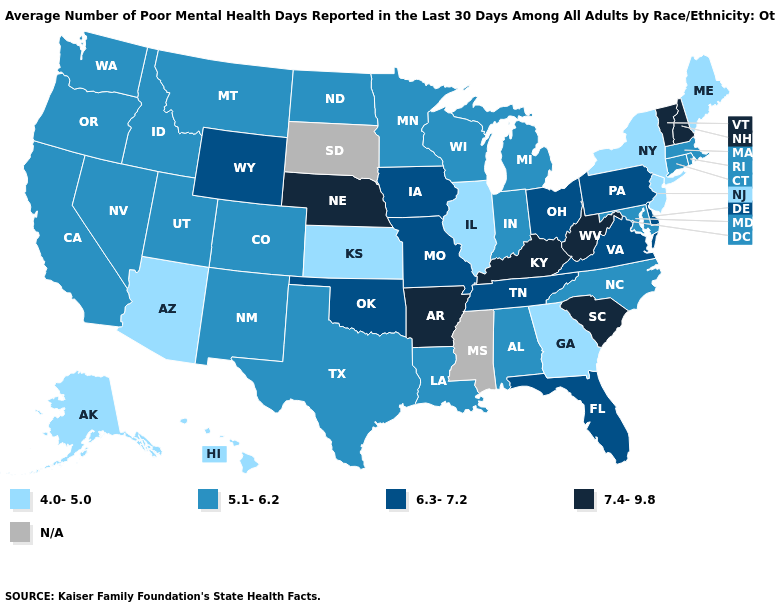Does Vermont have the highest value in the Northeast?
Keep it brief. Yes. Name the states that have a value in the range 5.1-6.2?
Concise answer only. Alabama, California, Colorado, Connecticut, Idaho, Indiana, Louisiana, Maryland, Massachusetts, Michigan, Minnesota, Montana, Nevada, New Mexico, North Carolina, North Dakota, Oregon, Rhode Island, Texas, Utah, Washington, Wisconsin. Among the states that border Missouri , which have the lowest value?
Give a very brief answer. Illinois, Kansas. What is the lowest value in the MidWest?
Short answer required. 4.0-5.0. What is the lowest value in states that border Louisiana?
Write a very short answer. 5.1-6.2. Which states have the lowest value in the MidWest?
Be succinct. Illinois, Kansas. Name the states that have a value in the range N/A?
Be succinct. Mississippi, South Dakota. Among the states that border Connecticut , does New York have the lowest value?
Write a very short answer. Yes. What is the value of New York?
Concise answer only. 4.0-5.0. Among the states that border Tennessee , does Kentucky have the highest value?
Keep it brief. Yes. Among the states that border Oregon , which have the highest value?
Short answer required. California, Idaho, Nevada, Washington. Among the states that border Nebraska , which have the lowest value?
Quick response, please. Kansas. Name the states that have a value in the range 6.3-7.2?
Short answer required. Delaware, Florida, Iowa, Missouri, Ohio, Oklahoma, Pennsylvania, Tennessee, Virginia, Wyoming. What is the highest value in states that border Nebraska?
Short answer required. 6.3-7.2. Does Hawaii have the highest value in the USA?
Keep it brief. No. 